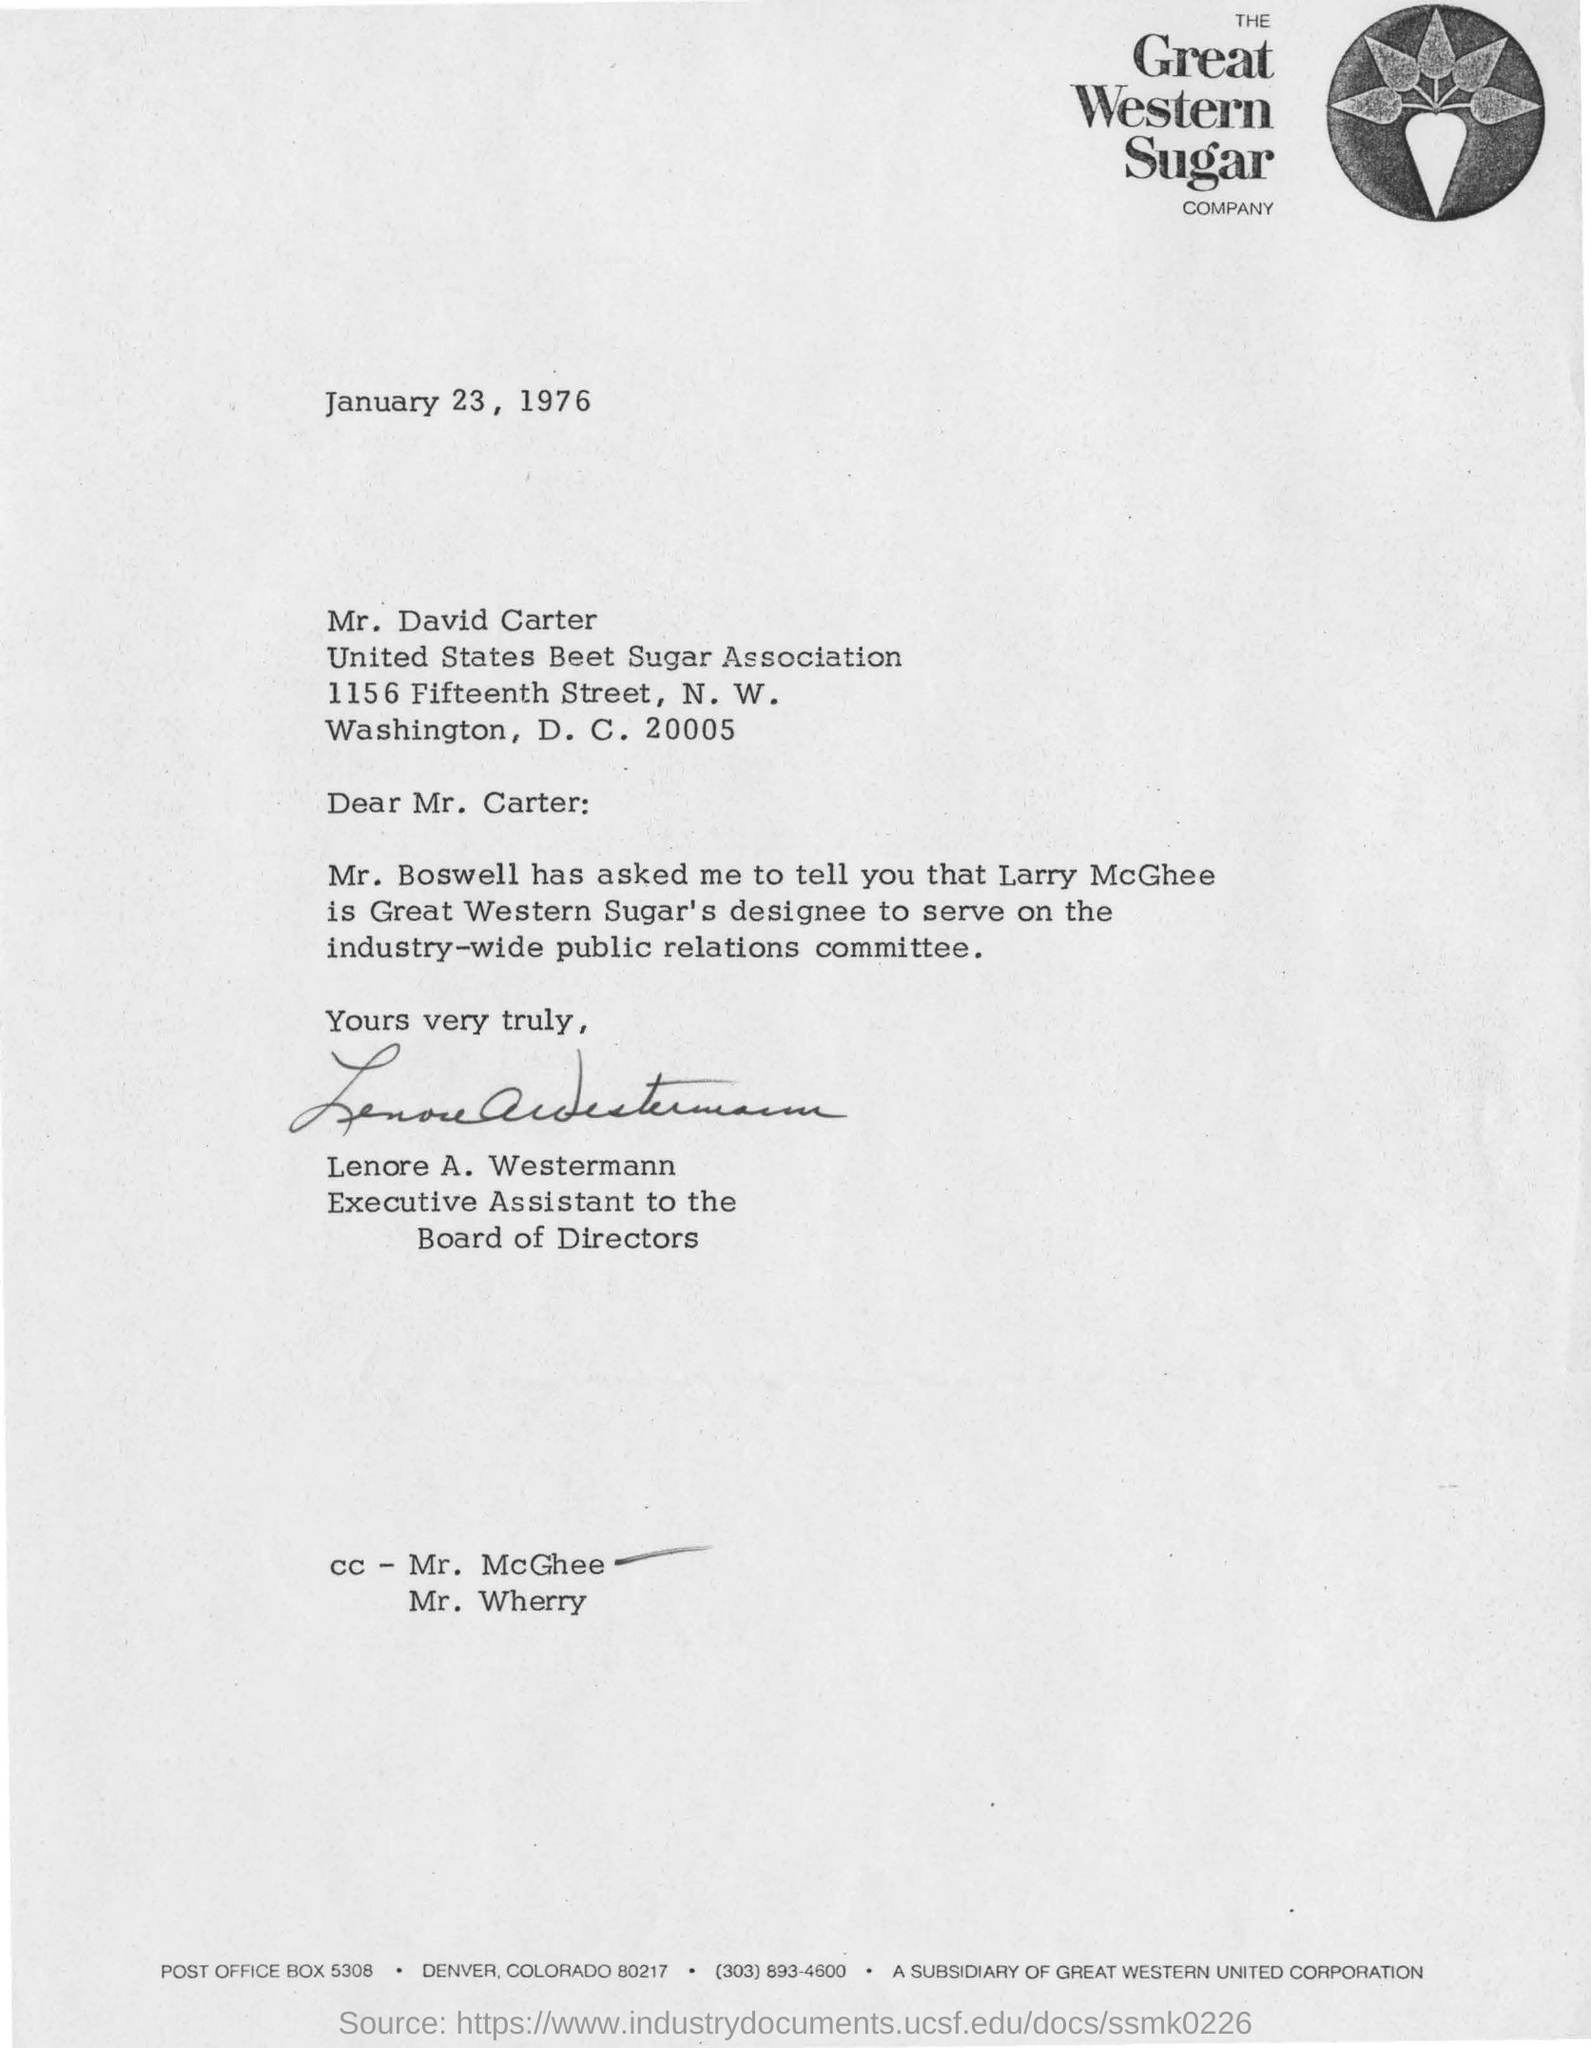Point out several critical features in this image. The sender of the letter is Lenore A. Westermann. The recipient of the letter is David Carter. The date in the letter is January 23, 1976. 